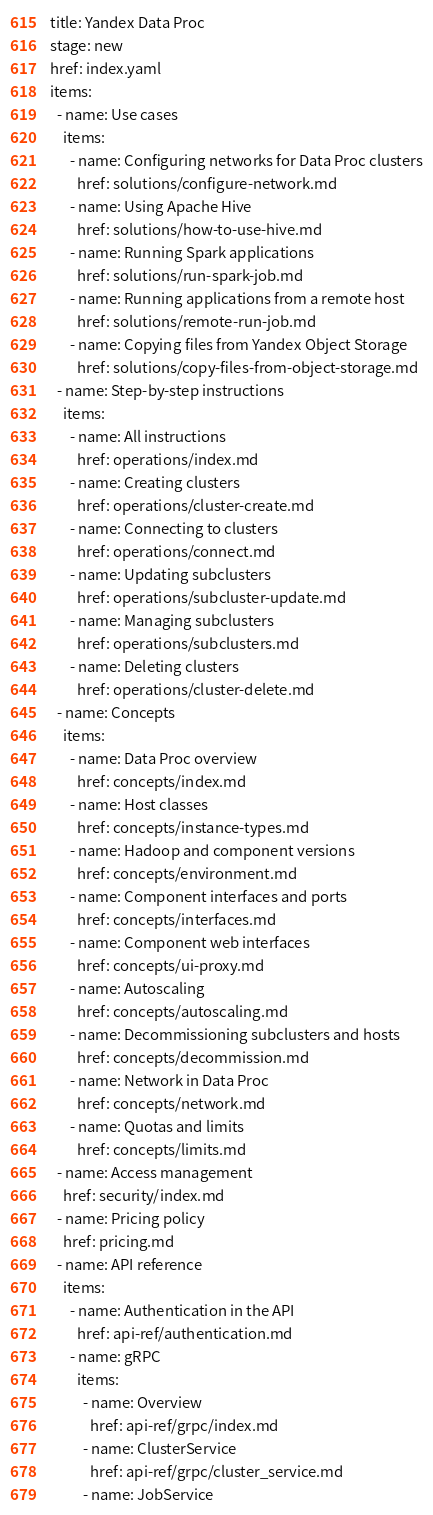Convert code to text. <code><loc_0><loc_0><loc_500><loc_500><_YAML_>title: Yandex Data Proc
stage: new
href: index.yaml
items:
  - name: Use cases
    items:
      - name: Configuring networks for Data Proc clusters
        href: solutions/configure-network.md
      - name: Using Apache Hive
        href: solutions/how-to-use-hive.md
      - name: Running Spark applications
        href: solutions/run-spark-job.md
      - name: Running applications from a remote host
        href: solutions/remote-run-job.md
      - name: Copying files from Yandex Object Storage
        href: solutions/copy-files-from-object-storage.md
  - name: Step-by-step instructions
    items:
      - name: All instructions
        href: operations/index.md
      - name: Creating clusters
        href: operations/cluster-create.md
      - name: Connecting to clusters
        href: operations/connect.md
      - name: Updating subclusters
        href: operations/subcluster-update.md
      - name: Managing subclusters
        href: operations/subclusters.md
      - name: Deleting clusters
        href: operations/cluster-delete.md
  - name: Concepts
    items:
      - name: Data Proc overview
        href: concepts/index.md
      - name: Host classes
        href: concepts/instance-types.md
      - name: Hadoop and component versions
        href: concepts/environment.md
      - name: Component interfaces and ports
        href: concepts/interfaces.md
      - name: Component web interfaces
        href: concepts/ui-proxy.md
      - name: Autoscaling
        href: concepts/autoscaling.md
      - name: Decommissioning subclusters and hosts
        href: concepts/decommission.md
      - name: Network in Data Proc
        href: concepts/network.md
      - name: Quotas and limits
        href: concepts/limits.md
  - name: Access management
    href: security/index.md
  - name: Pricing policy
    href: pricing.md
  - name: API reference
    items:
      - name: Authentication in the API
        href: api-ref/authentication.md
      - name: gRPC
        items:
          - name: Overview
            href: api-ref/grpc/index.md
          - name: ClusterService
            href: api-ref/grpc/cluster_service.md
          - name: JobService</code> 